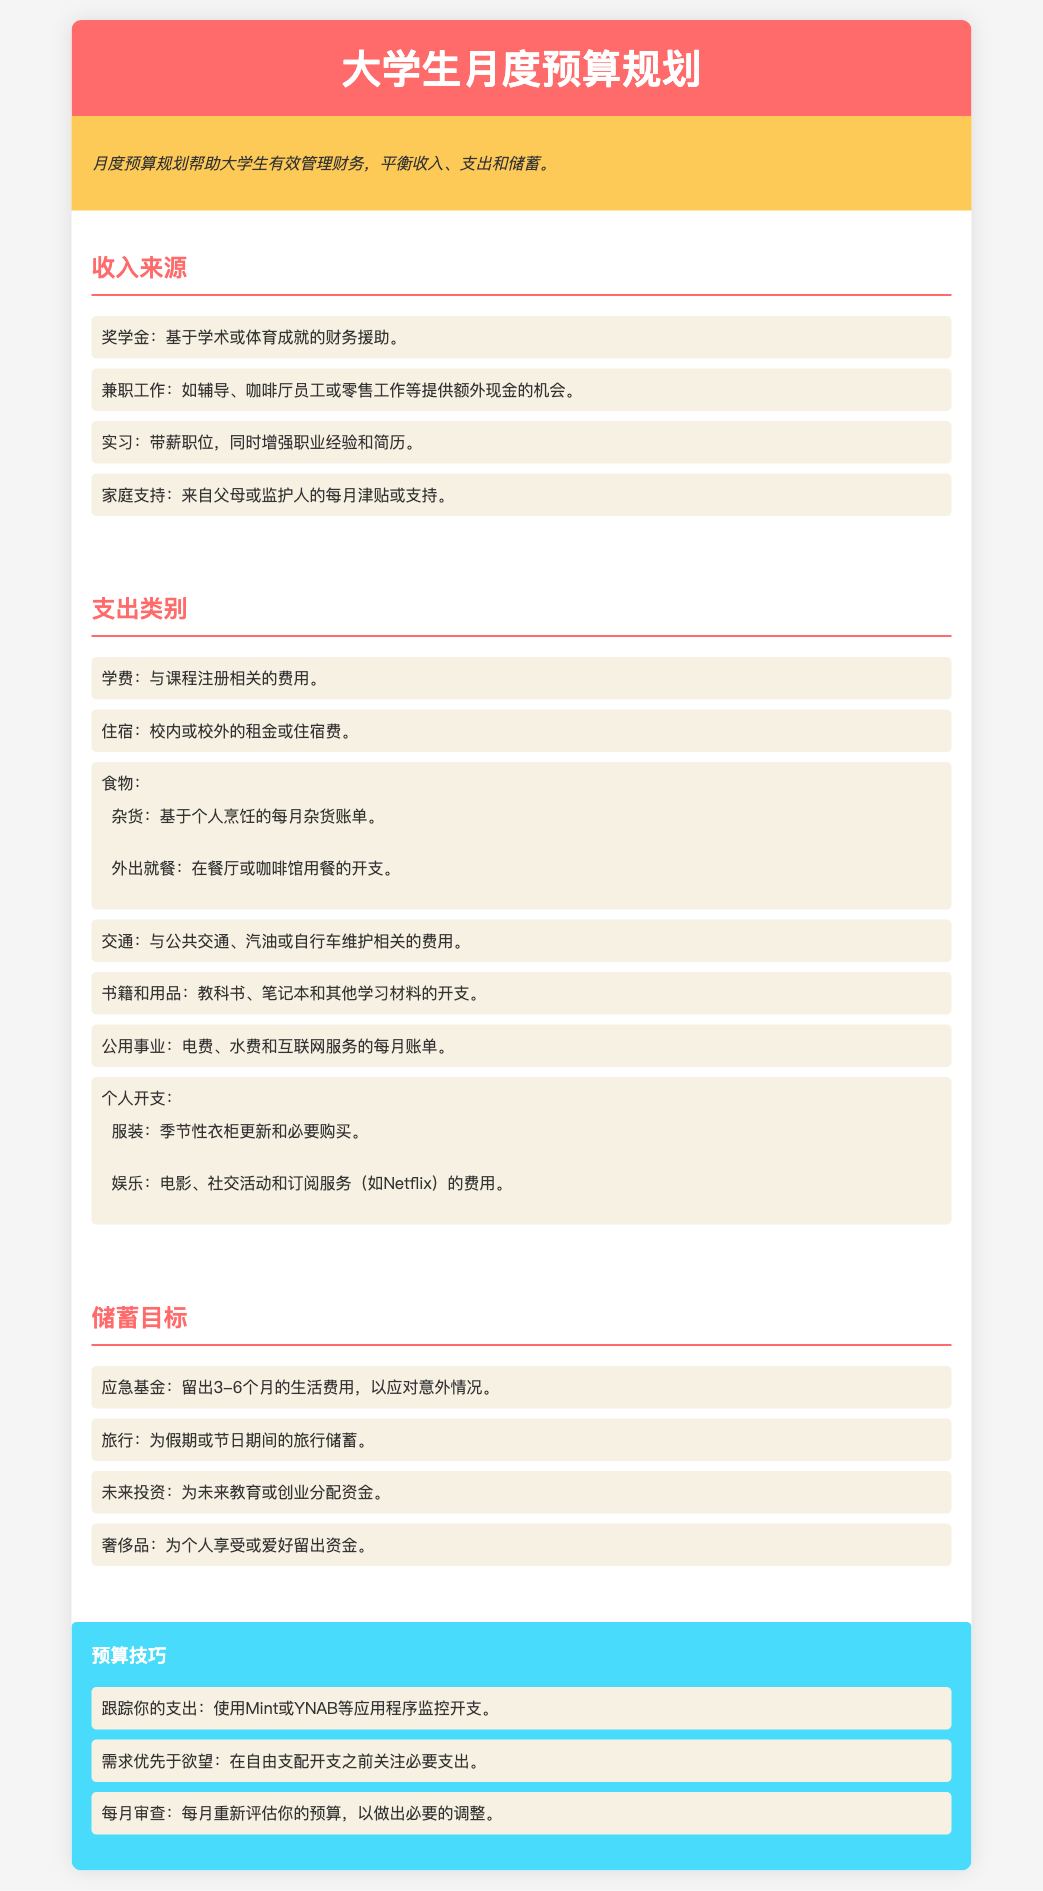收入来源包括哪些? 收入来源是在文档中列出的，包含奖学金、兼职工作、实习和家庭支持。
Answer: 奖学金、兼职工作、实习、家庭支持 学费属于哪个支出类别? 学费是支出类别中的一个项目，专门用于课程注册相关的费用。
Answer: 学费 有多少种储蓄目标? 储蓄目标在文档中列出了四个不同目标，包括应急基金、旅行、未来投资和奢侈品。
Answer: 四个 兼职工作的一个例子是什么? 文档中提到的兼职工作包括辅导、咖啡厅员工或零售工作等。
Answer: 辅导 预算技巧中提到了哪些应用程序? 预算技巧中提到的应用程序是Mint和YNAB，用于监控开支。
Answer: Mint、YNAB 应急基金的建议金额是多少? 文档建议留出3-6个月的生活费用作为应急基金。
Answer: 3-6个月 在支出类别中，个人开支包括哪些内容? 个人开支包含服装和娱乐这两个方面。
Answer: 服装、娱乐 文档中的主要主题是什么? 文档的主要主题是帮助大学生有效管理财务，平衡收入、支出和储蓄。
Answer: 财务管理 每月审查预算的目的是什么? 每月审查的目的是为了重新评估预算，以做出必要的调整。
Answer: 重新评估 外出就餐属于哪个支出类别? 外出就餐被列为食物类别下的一个支出项。
Answer: 食物 